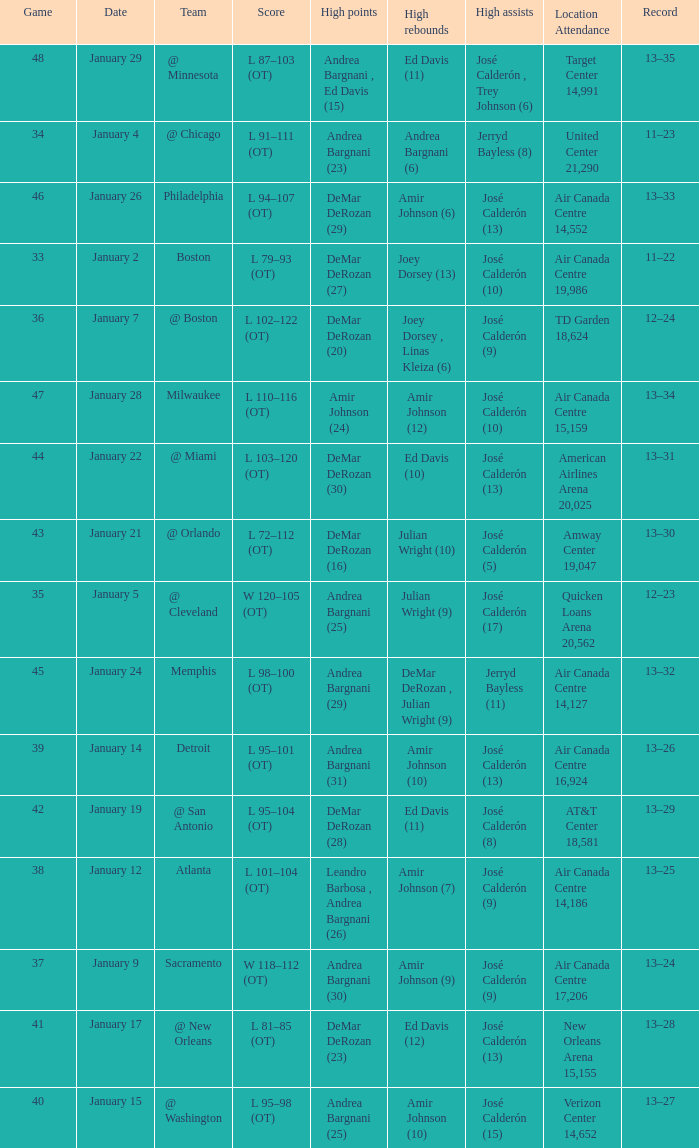Name the team for january 17 @ New Orleans. 